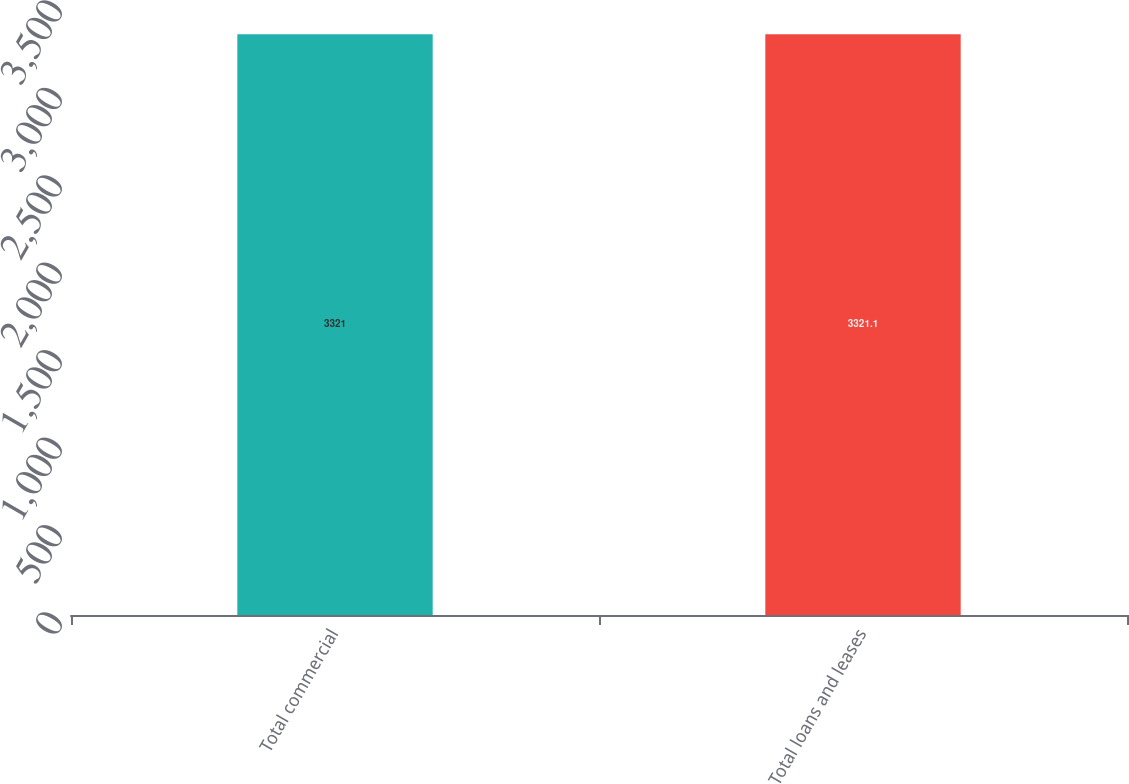<chart> <loc_0><loc_0><loc_500><loc_500><bar_chart><fcel>Total commercial<fcel>Total loans and leases<nl><fcel>3321<fcel>3321.1<nl></chart> 